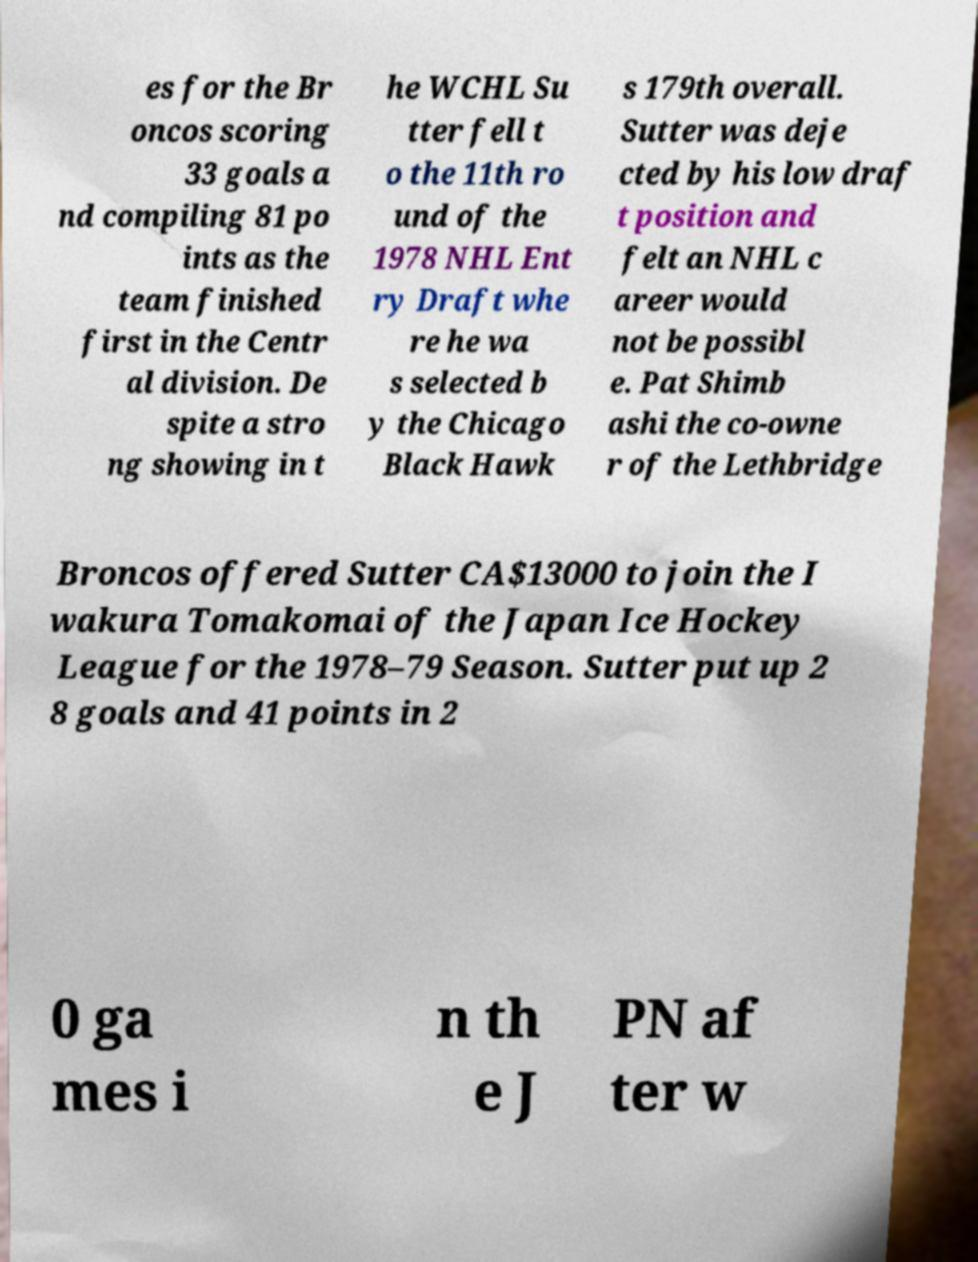Could you assist in decoding the text presented in this image and type it out clearly? es for the Br oncos scoring 33 goals a nd compiling 81 po ints as the team finished first in the Centr al division. De spite a stro ng showing in t he WCHL Su tter fell t o the 11th ro und of the 1978 NHL Ent ry Draft whe re he wa s selected b y the Chicago Black Hawk s 179th overall. Sutter was deje cted by his low draf t position and felt an NHL c areer would not be possibl e. Pat Shimb ashi the co-owne r of the Lethbridge Broncos offered Sutter CA$13000 to join the I wakura Tomakomai of the Japan Ice Hockey League for the 1978–79 Season. Sutter put up 2 8 goals and 41 points in 2 0 ga mes i n th e J PN af ter w 